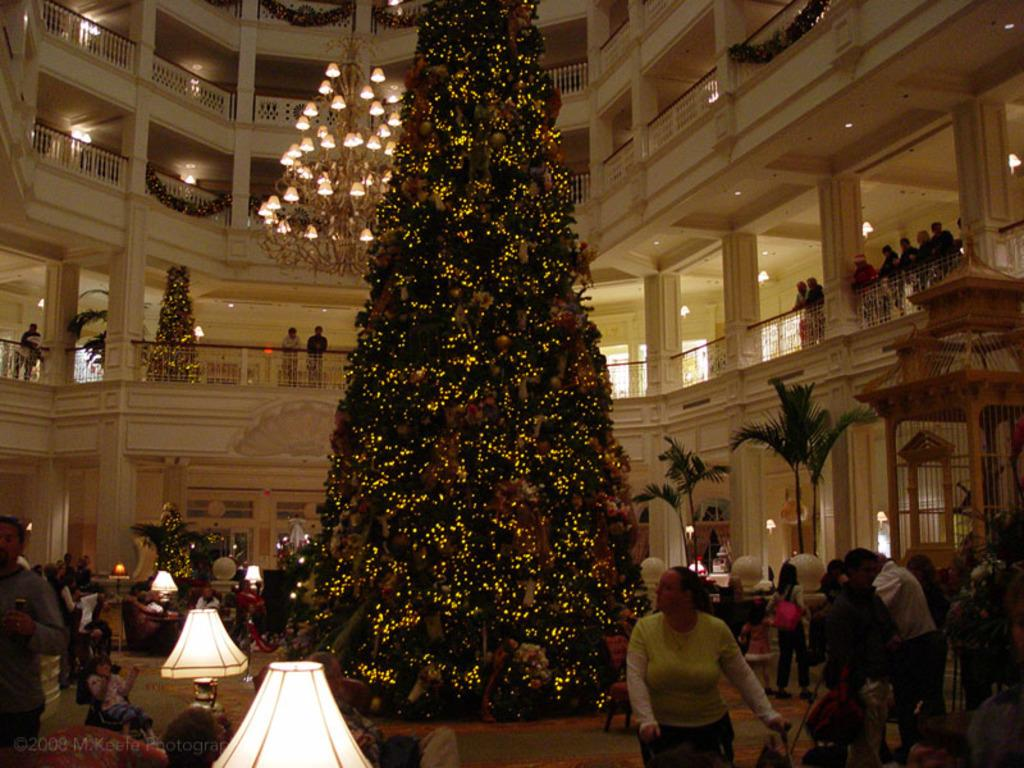How many people can be seen in the image? There are many people standing on the ground floor in the image. What is visible behind the people? There are trees visible behind the people. What type of lighting is present in the image? There are lamps and a chandelier visible in the image. Where is the chandelier located in the image? The chandelier is visible on the top of the image. What type of beam is holding up the ceiling in the image? There is no beam visible in the image; it only shows people, trees, lamps, and a chandelier. How many cats can be seen playing in the snow in the image? There are no cats or snow present in the image. 